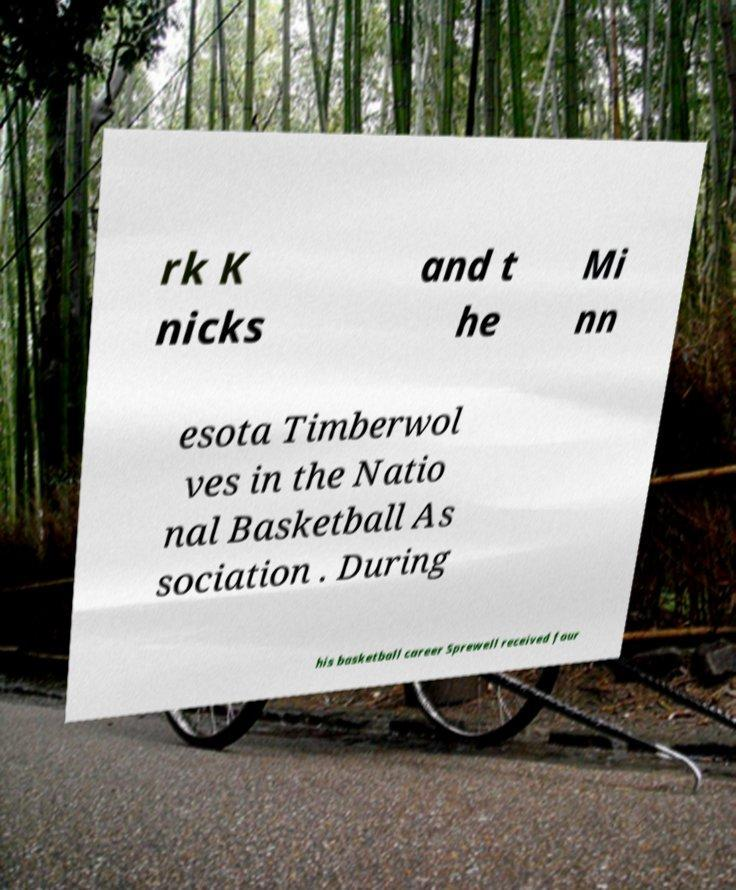Can you accurately transcribe the text from the provided image for me? rk K nicks and t he Mi nn esota Timberwol ves in the Natio nal Basketball As sociation . During his basketball career Sprewell received four 